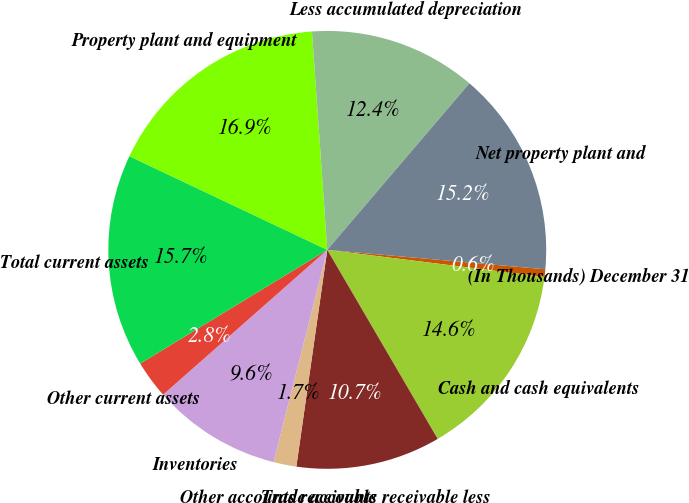<chart> <loc_0><loc_0><loc_500><loc_500><pie_chart><fcel>(In Thousands) December 31<fcel>Cash and cash equivalents<fcel>Trade accounts receivable less<fcel>Other accounts receivable<fcel>Inventories<fcel>Other current assets<fcel>Total current assets<fcel>Property plant and equipment<fcel>Less accumulated depreciation<fcel>Net property plant and<nl><fcel>0.56%<fcel>14.61%<fcel>10.67%<fcel>1.69%<fcel>9.55%<fcel>2.81%<fcel>15.73%<fcel>16.85%<fcel>12.36%<fcel>15.17%<nl></chart> 